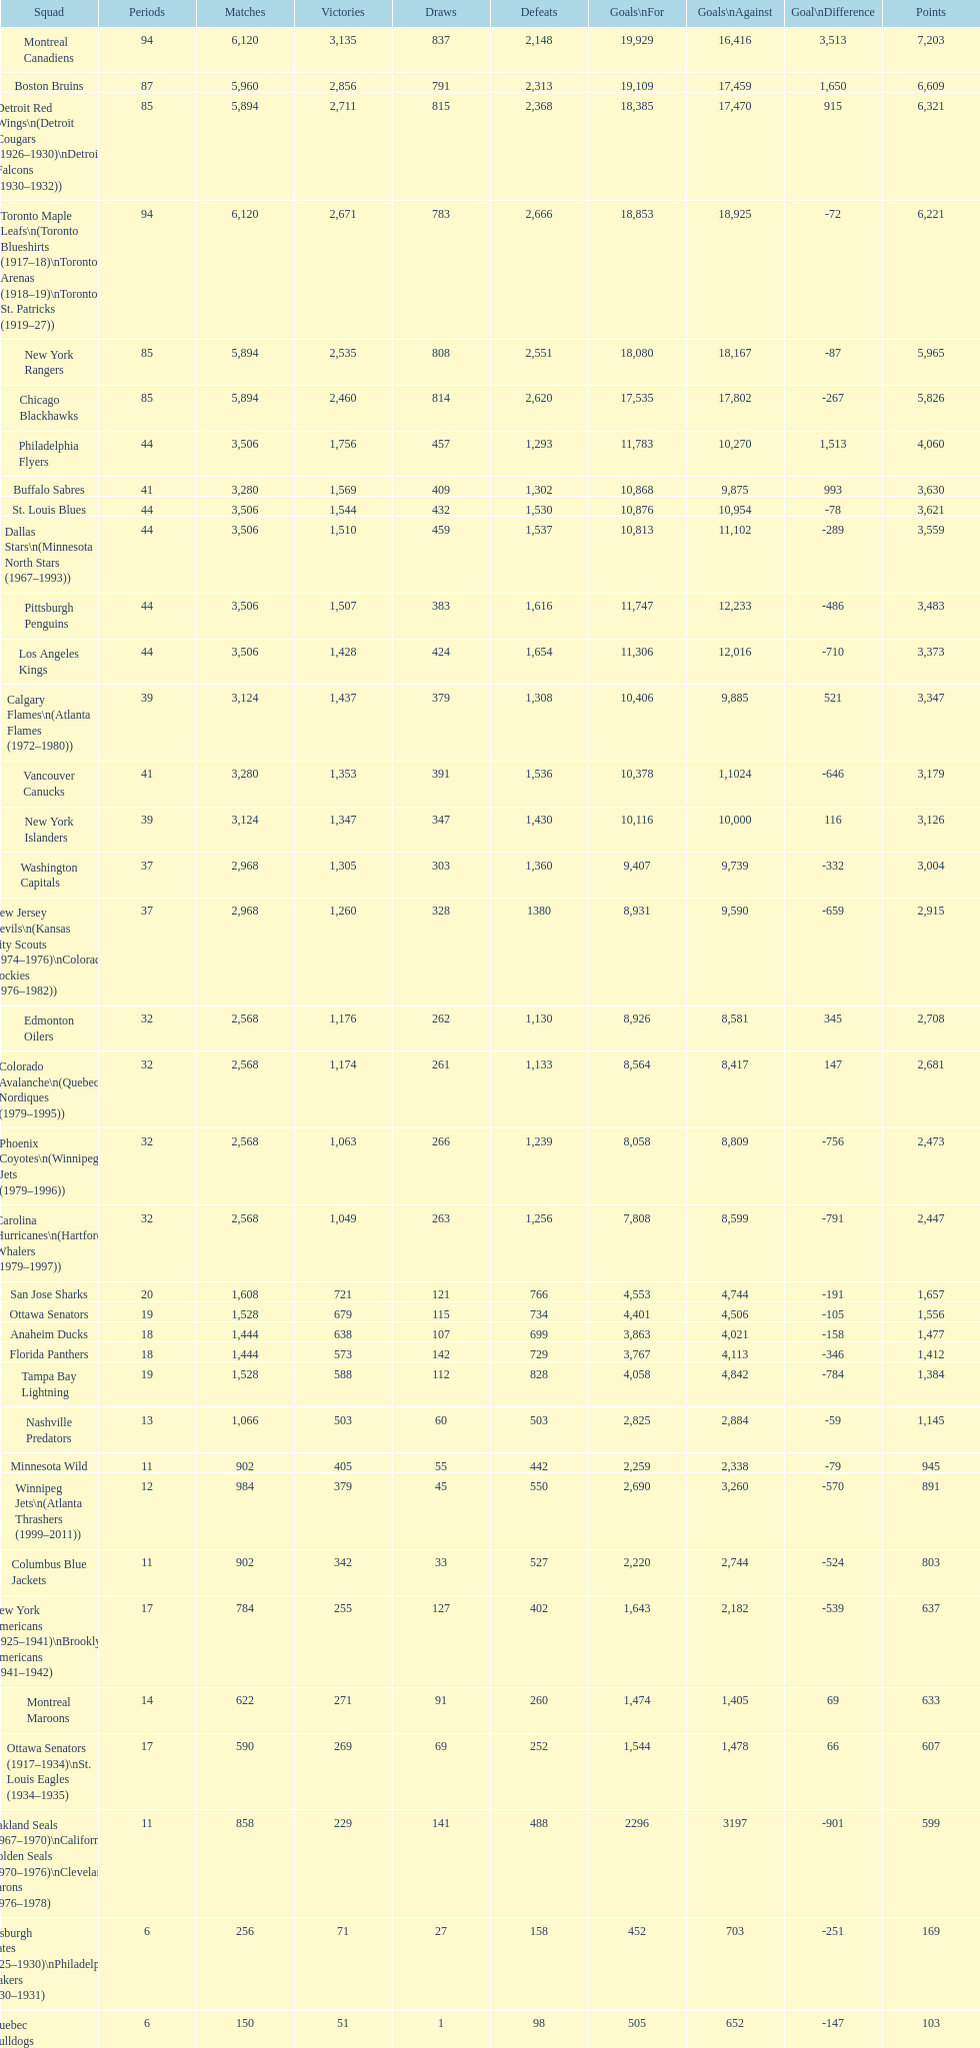How many total points has the lost angeles kings scored? 3,373. 